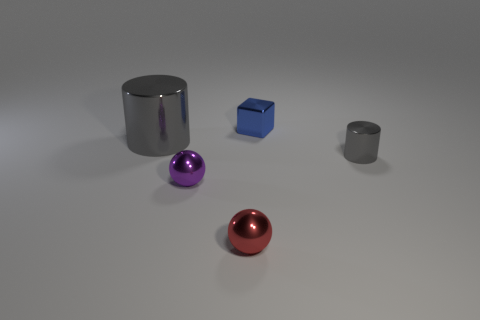How big is the red sphere?
Offer a very short reply. Small. There is a cylinder that is made of the same material as the big object; what is its color?
Your response must be concise. Gray. How many small yellow things have the same material as the large cylinder?
Provide a short and direct response. 0. Does the tiny metallic cube have the same color as the cylinder that is on the left side of the metallic block?
Your answer should be very brief. No. The small object behind the gray thing to the left of the blue metal object is what color?
Keep it short and to the point. Blue. The cylinder that is the same size as the red metallic ball is what color?
Make the answer very short. Gray. Are there any gray objects of the same shape as the small blue thing?
Offer a very short reply. No. What is the shape of the large gray object?
Your response must be concise. Cylinder. Is the number of big shiny cylinders that are left of the big cylinder greater than the number of purple shiny spheres that are behind the tiny cube?
Your answer should be compact. No. What number of other things are there of the same size as the red metallic object?
Provide a succinct answer. 3. 